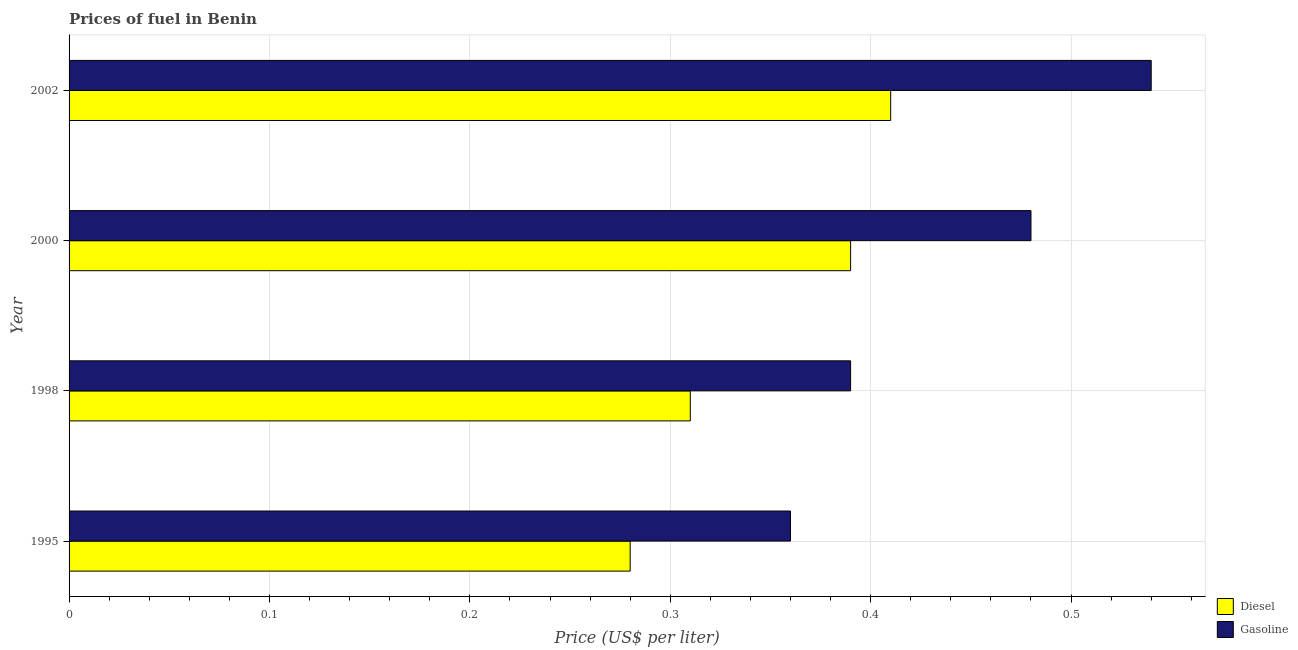How many different coloured bars are there?
Keep it short and to the point. 2. Are the number of bars per tick equal to the number of legend labels?
Give a very brief answer. Yes. Are the number of bars on each tick of the Y-axis equal?
Make the answer very short. Yes. How many bars are there on the 1st tick from the bottom?
Keep it short and to the point. 2. What is the label of the 2nd group of bars from the top?
Ensure brevity in your answer.  2000. In how many cases, is the number of bars for a given year not equal to the number of legend labels?
Keep it short and to the point. 0. What is the diesel price in 2000?
Your answer should be very brief. 0.39. Across all years, what is the maximum diesel price?
Ensure brevity in your answer.  0.41. Across all years, what is the minimum gasoline price?
Offer a very short reply. 0.36. In which year was the diesel price minimum?
Your answer should be very brief. 1995. What is the total diesel price in the graph?
Make the answer very short. 1.39. What is the difference between the gasoline price in 2000 and that in 2002?
Your response must be concise. -0.06. What is the difference between the diesel price in 1998 and the gasoline price in 2000?
Ensure brevity in your answer.  -0.17. What is the average diesel price per year?
Your answer should be very brief. 0.35. In the year 1995, what is the difference between the gasoline price and diesel price?
Your answer should be very brief. 0.08. In how many years, is the diesel price greater than 0.06 US$ per litre?
Offer a terse response. 4. What is the ratio of the diesel price in 1998 to that in 2000?
Provide a short and direct response. 0.8. Is the gasoline price in 1995 less than that in 2000?
Keep it short and to the point. Yes. What is the difference between the highest and the lowest diesel price?
Provide a short and direct response. 0.13. In how many years, is the diesel price greater than the average diesel price taken over all years?
Offer a very short reply. 2. What does the 2nd bar from the top in 2000 represents?
Ensure brevity in your answer.  Diesel. What does the 1st bar from the bottom in 2000 represents?
Your answer should be compact. Diesel. Are all the bars in the graph horizontal?
Provide a succinct answer. Yes. How many years are there in the graph?
Give a very brief answer. 4. Where does the legend appear in the graph?
Your response must be concise. Bottom right. How are the legend labels stacked?
Offer a very short reply. Vertical. What is the title of the graph?
Ensure brevity in your answer.  Prices of fuel in Benin. What is the label or title of the X-axis?
Your answer should be compact. Price (US$ per liter). What is the label or title of the Y-axis?
Your answer should be very brief. Year. What is the Price (US$ per liter) in Diesel in 1995?
Keep it short and to the point. 0.28. What is the Price (US$ per liter) in Gasoline in 1995?
Your response must be concise. 0.36. What is the Price (US$ per liter) in Diesel in 1998?
Your response must be concise. 0.31. What is the Price (US$ per liter) in Gasoline in 1998?
Give a very brief answer. 0.39. What is the Price (US$ per liter) in Diesel in 2000?
Your answer should be compact. 0.39. What is the Price (US$ per liter) in Gasoline in 2000?
Your answer should be compact. 0.48. What is the Price (US$ per liter) in Diesel in 2002?
Your answer should be compact. 0.41. What is the Price (US$ per liter) in Gasoline in 2002?
Give a very brief answer. 0.54. Across all years, what is the maximum Price (US$ per liter) in Diesel?
Make the answer very short. 0.41. Across all years, what is the maximum Price (US$ per liter) of Gasoline?
Offer a very short reply. 0.54. Across all years, what is the minimum Price (US$ per liter) in Diesel?
Your answer should be compact. 0.28. Across all years, what is the minimum Price (US$ per liter) of Gasoline?
Provide a succinct answer. 0.36. What is the total Price (US$ per liter) in Diesel in the graph?
Provide a short and direct response. 1.39. What is the total Price (US$ per liter) in Gasoline in the graph?
Your response must be concise. 1.77. What is the difference between the Price (US$ per liter) of Diesel in 1995 and that in 1998?
Your answer should be very brief. -0.03. What is the difference between the Price (US$ per liter) of Gasoline in 1995 and that in 1998?
Offer a very short reply. -0.03. What is the difference between the Price (US$ per liter) of Diesel in 1995 and that in 2000?
Give a very brief answer. -0.11. What is the difference between the Price (US$ per liter) in Gasoline in 1995 and that in 2000?
Offer a very short reply. -0.12. What is the difference between the Price (US$ per liter) of Diesel in 1995 and that in 2002?
Provide a short and direct response. -0.13. What is the difference between the Price (US$ per liter) in Gasoline in 1995 and that in 2002?
Provide a succinct answer. -0.18. What is the difference between the Price (US$ per liter) of Diesel in 1998 and that in 2000?
Give a very brief answer. -0.08. What is the difference between the Price (US$ per liter) in Gasoline in 1998 and that in 2000?
Offer a terse response. -0.09. What is the difference between the Price (US$ per liter) in Diesel in 1998 and that in 2002?
Keep it short and to the point. -0.1. What is the difference between the Price (US$ per liter) of Gasoline in 1998 and that in 2002?
Provide a succinct answer. -0.15. What is the difference between the Price (US$ per liter) of Diesel in 2000 and that in 2002?
Your answer should be compact. -0.02. What is the difference between the Price (US$ per liter) of Gasoline in 2000 and that in 2002?
Your answer should be compact. -0.06. What is the difference between the Price (US$ per liter) of Diesel in 1995 and the Price (US$ per liter) of Gasoline in 1998?
Offer a terse response. -0.11. What is the difference between the Price (US$ per liter) in Diesel in 1995 and the Price (US$ per liter) in Gasoline in 2000?
Your answer should be compact. -0.2. What is the difference between the Price (US$ per liter) of Diesel in 1995 and the Price (US$ per liter) of Gasoline in 2002?
Keep it short and to the point. -0.26. What is the difference between the Price (US$ per liter) in Diesel in 1998 and the Price (US$ per liter) in Gasoline in 2000?
Your answer should be very brief. -0.17. What is the difference between the Price (US$ per liter) of Diesel in 1998 and the Price (US$ per liter) of Gasoline in 2002?
Ensure brevity in your answer.  -0.23. What is the difference between the Price (US$ per liter) of Diesel in 2000 and the Price (US$ per liter) of Gasoline in 2002?
Provide a succinct answer. -0.15. What is the average Price (US$ per liter) of Diesel per year?
Make the answer very short. 0.35. What is the average Price (US$ per liter) of Gasoline per year?
Make the answer very short. 0.44. In the year 1995, what is the difference between the Price (US$ per liter) in Diesel and Price (US$ per liter) in Gasoline?
Your answer should be compact. -0.08. In the year 1998, what is the difference between the Price (US$ per liter) in Diesel and Price (US$ per liter) in Gasoline?
Your answer should be very brief. -0.08. In the year 2000, what is the difference between the Price (US$ per liter) in Diesel and Price (US$ per liter) in Gasoline?
Your answer should be very brief. -0.09. In the year 2002, what is the difference between the Price (US$ per liter) in Diesel and Price (US$ per liter) in Gasoline?
Make the answer very short. -0.13. What is the ratio of the Price (US$ per liter) of Diesel in 1995 to that in 1998?
Ensure brevity in your answer.  0.9. What is the ratio of the Price (US$ per liter) in Gasoline in 1995 to that in 1998?
Keep it short and to the point. 0.92. What is the ratio of the Price (US$ per liter) in Diesel in 1995 to that in 2000?
Make the answer very short. 0.72. What is the ratio of the Price (US$ per liter) of Diesel in 1995 to that in 2002?
Provide a short and direct response. 0.68. What is the ratio of the Price (US$ per liter) of Gasoline in 1995 to that in 2002?
Offer a terse response. 0.67. What is the ratio of the Price (US$ per liter) of Diesel in 1998 to that in 2000?
Provide a succinct answer. 0.79. What is the ratio of the Price (US$ per liter) of Gasoline in 1998 to that in 2000?
Offer a terse response. 0.81. What is the ratio of the Price (US$ per liter) in Diesel in 1998 to that in 2002?
Your answer should be very brief. 0.76. What is the ratio of the Price (US$ per liter) of Gasoline in 1998 to that in 2002?
Offer a terse response. 0.72. What is the ratio of the Price (US$ per liter) in Diesel in 2000 to that in 2002?
Ensure brevity in your answer.  0.95. What is the ratio of the Price (US$ per liter) of Gasoline in 2000 to that in 2002?
Your response must be concise. 0.89. What is the difference between the highest and the second highest Price (US$ per liter) in Gasoline?
Make the answer very short. 0.06. What is the difference between the highest and the lowest Price (US$ per liter) of Diesel?
Ensure brevity in your answer.  0.13. What is the difference between the highest and the lowest Price (US$ per liter) of Gasoline?
Give a very brief answer. 0.18. 